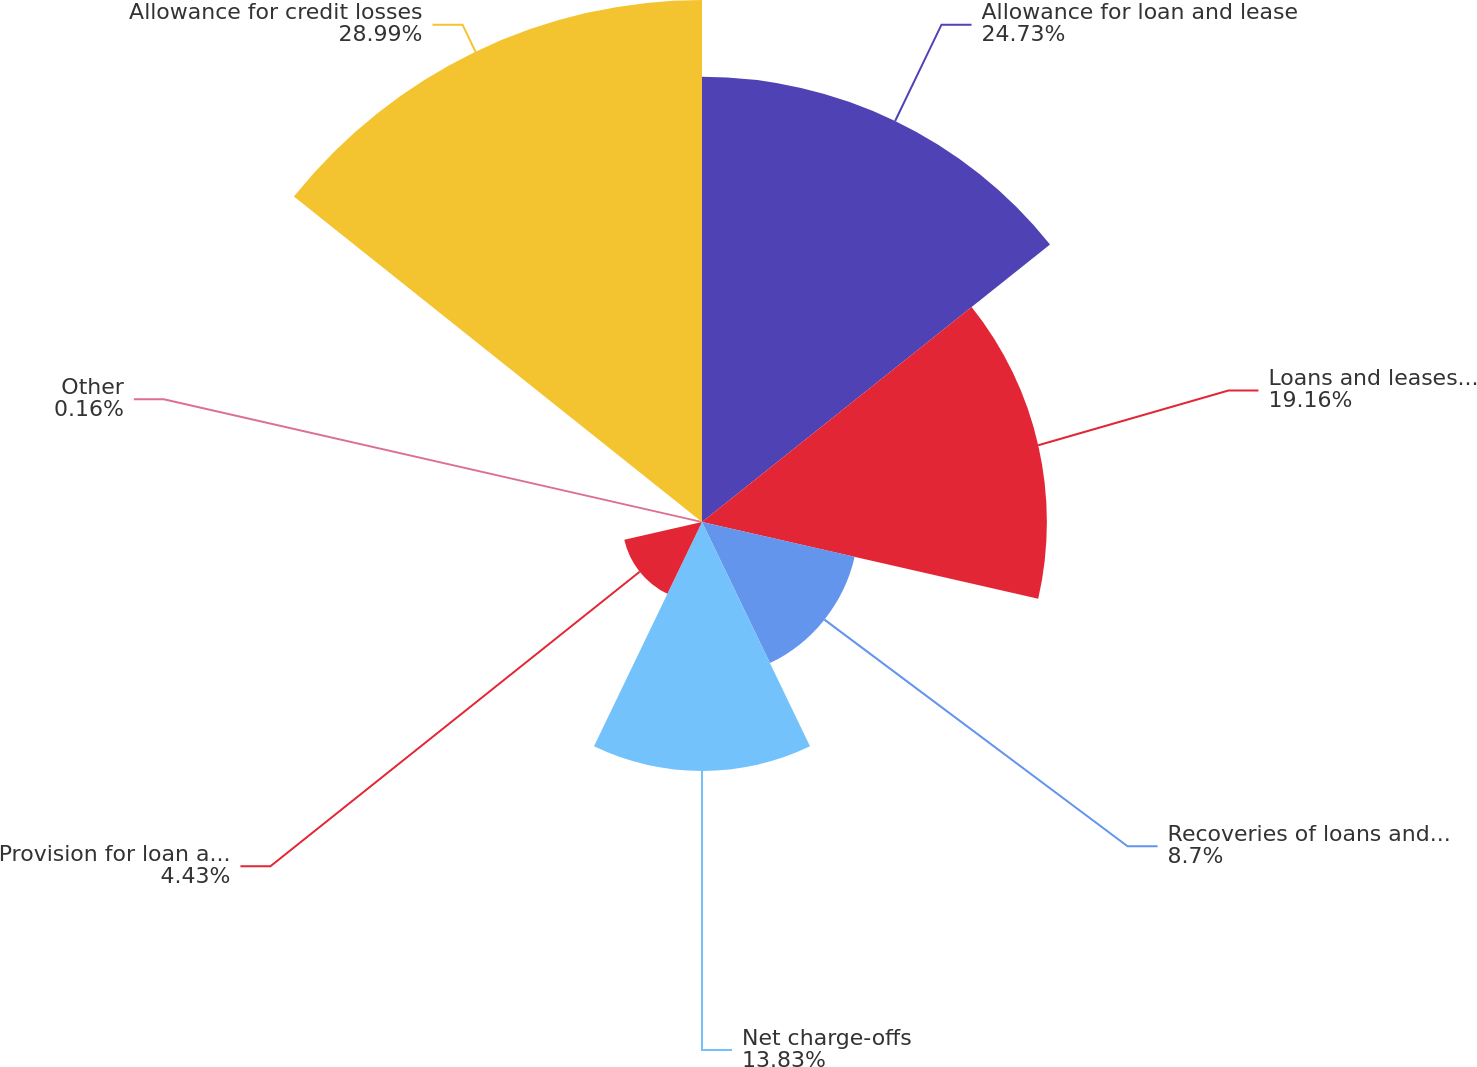Convert chart to OTSL. <chart><loc_0><loc_0><loc_500><loc_500><pie_chart><fcel>Allowance for loan and lease<fcel>Loans and leases charged off<fcel>Recoveries of loans and leases<fcel>Net charge-offs<fcel>Provision for loan and lease<fcel>Other<fcel>Allowance for credit losses<nl><fcel>24.73%<fcel>19.16%<fcel>8.7%<fcel>13.83%<fcel>4.43%<fcel>0.16%<fcel>29.0%<nl></chart> 